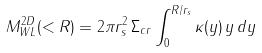<formula> <loc_0><loc_0><loc_500><loc_500>M _ { W L } ^ { 2 D } ( < R ) = 2 \pi r _ { s } ^ { 2 } \, \Sigma _ { c r } \int _ { 0 } ^ { R / r _ { s } } \kappa ( y ) \, y \, d y</formula> 